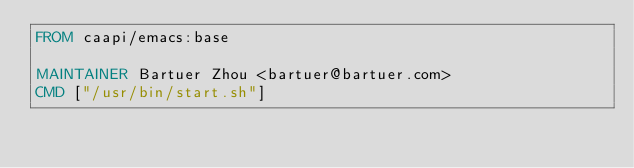Convert code to text. <code><loc_0><loc_0><loc_500><loc_500><_Dockerfile_>FROM caapi/emacs:base

MAINTAINER Bartuer Zhou <bartuer@bartuer.com>
CMD ["/usr/bin/start.sh"]
</code> 